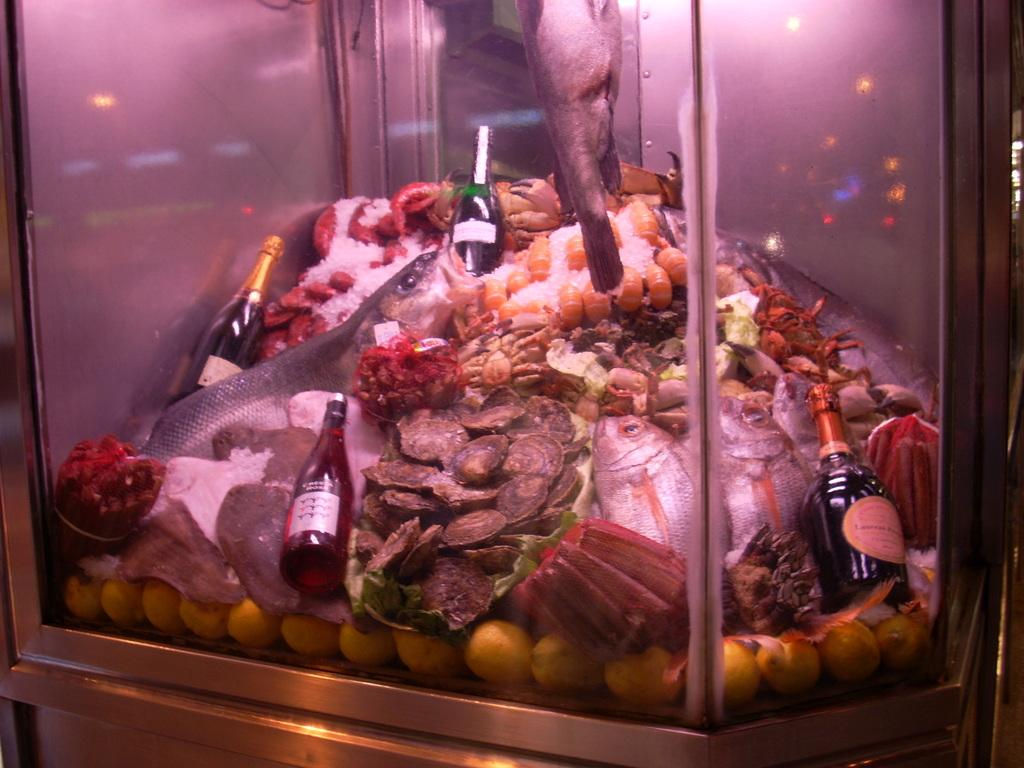What is the main subject of the picture? The main subject of the picture is an aquarium. What types of creatures can be seen in the aquarium? There are fishes and oysters in the aquarium. Are there any other objects in the aquarium besides the creatures? Yes, there are bottles and many food items in the aquarium. What type of beast can be seen climbing the wall in the image? There is no beast climbing the wall in the image, as the image features an aquarium with fishes, oysters, bottles, and food items. 